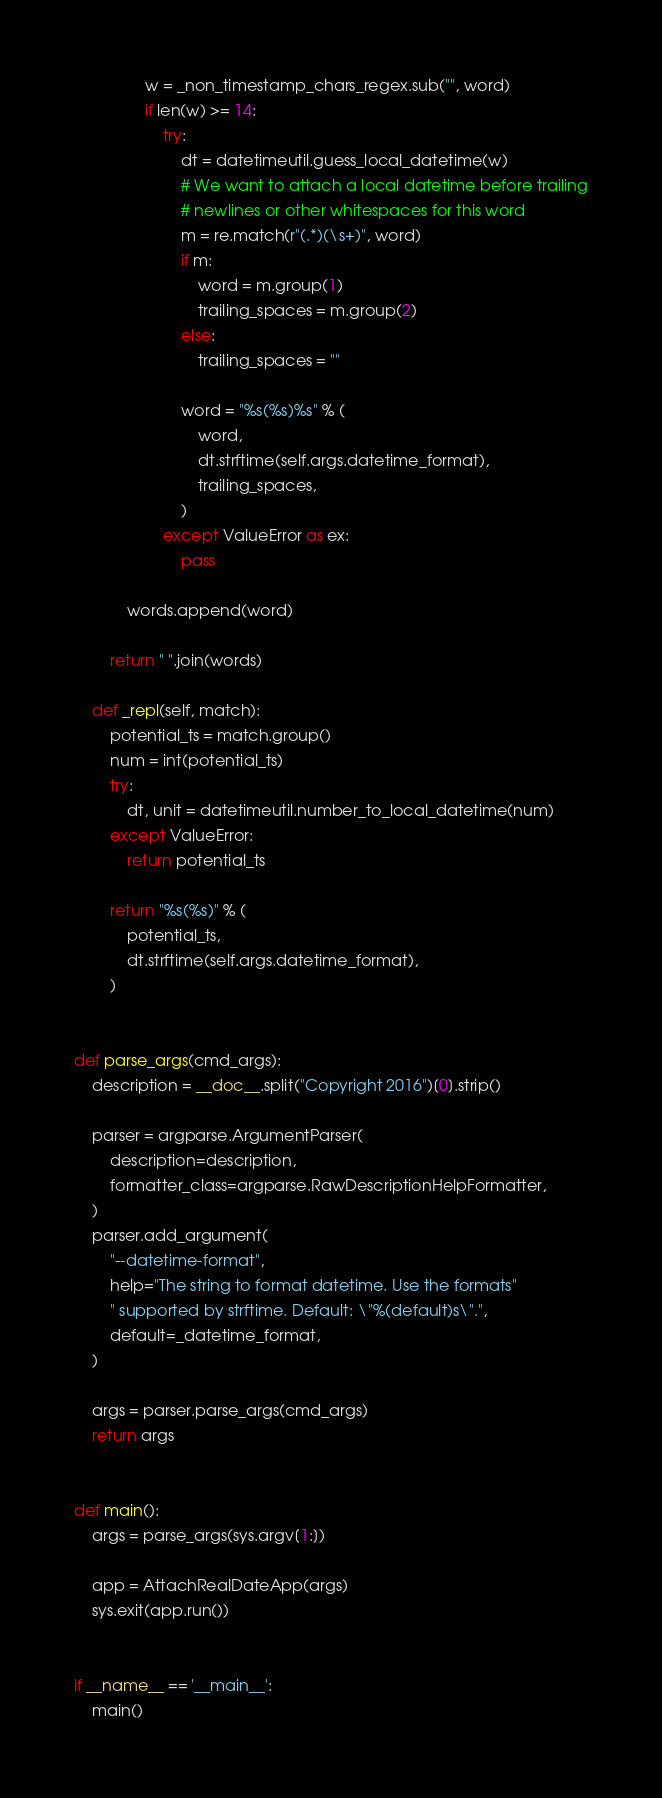<code> <loc_0><loc_0><loc_500><loc_500><_Python_>                w = _non_timestamp_chars_regex.sub("", word)
                if len(w) >= 14:
                    try:
                        dt = datetimeutil.guess_local_datetime(w)
                        # We want to attach a local datetime before trailing
                        # newlines or other whitespaces for this word
                        m = re.match(r"(.*)(\s+)", word)
                        if m:
                            word = m.group(1)
                            trailing_spaces = m.group(2)
                        else:
                            trailing_spaces = ""

                        word = "%s(%s)%s" % (
                            word,
                            dt.strftime(self.args.datetime_format),
                            trailing_spaces,
                        )
                    except ValueError as ex:
                        pass

            words.append(word)

        return " ".join(words)

    def _repl(self, match):
        potential_ts = match.group()
        num = int(potential_ts)
        try:
            dt, unit = datetimeutil.number_to_local_datetime(num)
        except ValueError:
            return potential_ts

        return "%s(%s)" % (
            potential_ts,
            dt.strftime(self.args.datetime_format),
        )


def parse_args(cmd_args):
    description = __doc__.split("Copyright 2016")[0].strip()

    parser = argparse.ArgumentParser(
        description=description,
        formatter_class=argparse.RawDescriptionHelpFormatter,
    )
    parser.add_argument(
        "--datetime-format",
        help="The string to format datetime. Use the formats"
        " supported by strftime. Default: \"%(default)s\".",
        default=_datetime_format,
    )

    args = parser.parse_args(cmd_args)
    return args


def main():
    args = parse_args(sys.argv[1:])

    app = AttachRealDateApp(args)
    sys.exit(app.run())


if __name__ == '__main__':
    main()
</code> 